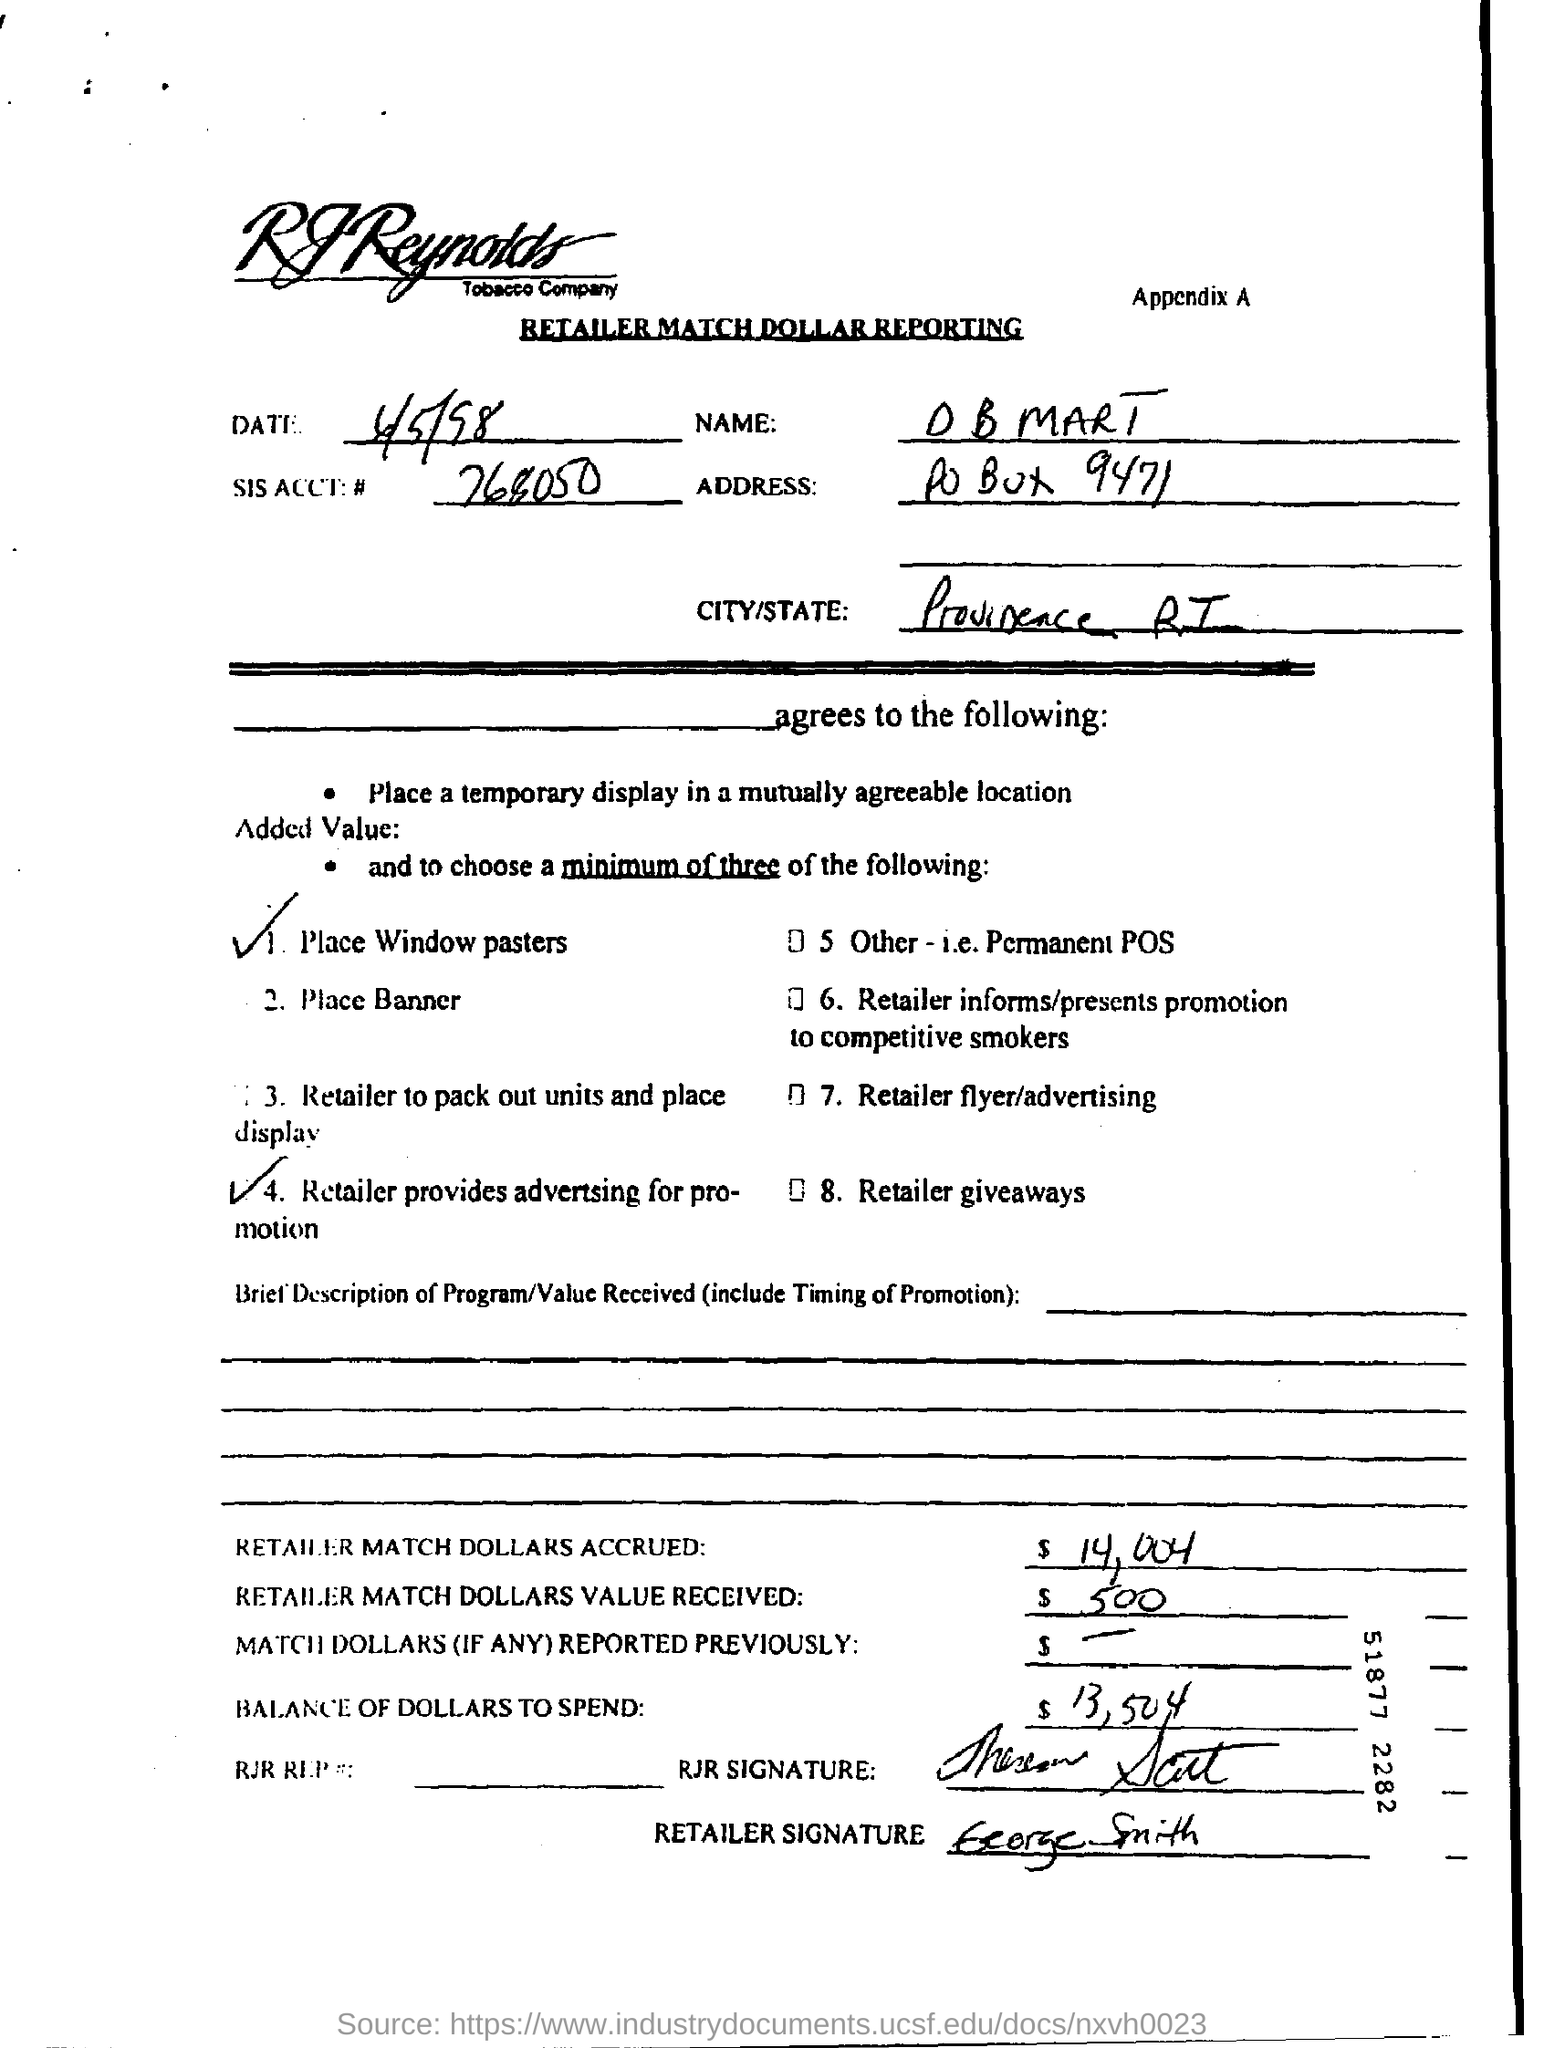Specify some key components in this picture. The name mentioned is 'O B MART.' 